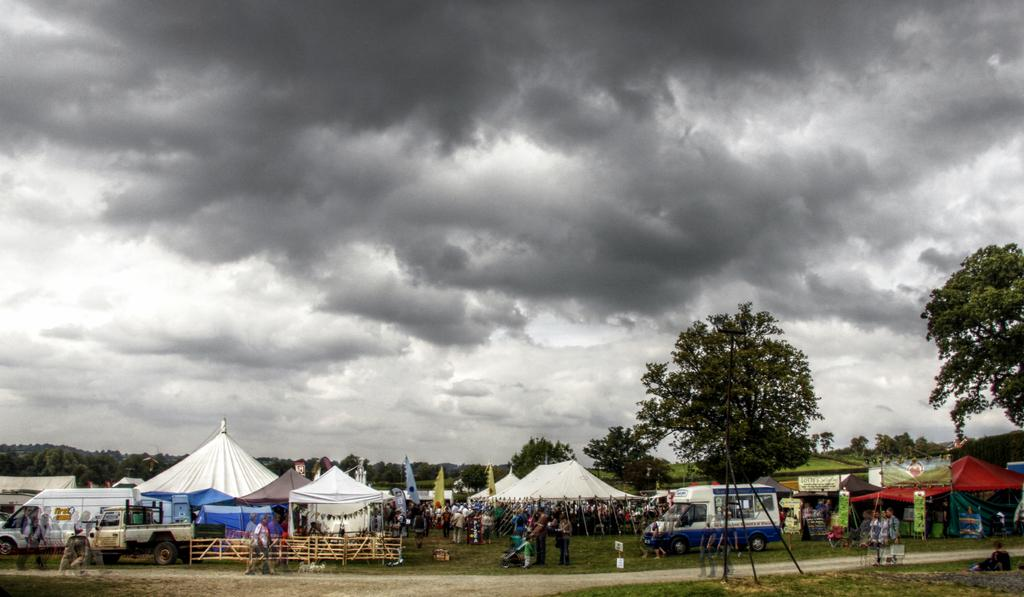What type of temporary shelters can be seen in the image? There are tents in the image. What are the flags associated with in the image? The flags are associated with the tents in the image. What type of transportation is visible in the image? There are vehicles in the image. What type of natural vegetation is present in the image? There are trees in the image. What type of barrier is present in the image? There is fencing in the image. What is the color scheme of the sky in the image? The sky is in black and white color in the image. What type of scientific discovery can be seen in the image? There is no scientific discovery present in the image. What type of coil is used to hold the tents in the image? There is no coil present in the image; the tents are supported by poles. 